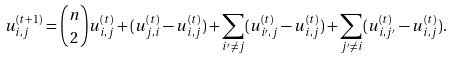<formula> <loc_0><loc_0><loc_500><loc_500>u ^ { ( t + 1 ) } _ { i , j } = \binom { n } { 2 } u ^ { ( t ) } _ { i , j } + ( u ^ { ( t ) } _ { j , i } - u ^ { ( t ) } _ { i , j } ) + \sum _ { i ^ { \prime } \ne j } ( u ^ { ( t ) } _ { i ^ { \prime } , j } - u ^ { ( t ) } _ { i , j } ) + \sum _ { j ^ { \prime } \ne i } ( u ^ { ( t ) } _ { i , j ^ { \prime } } - u ^ { ( t ) } _ { i , j } ) .</formula> 